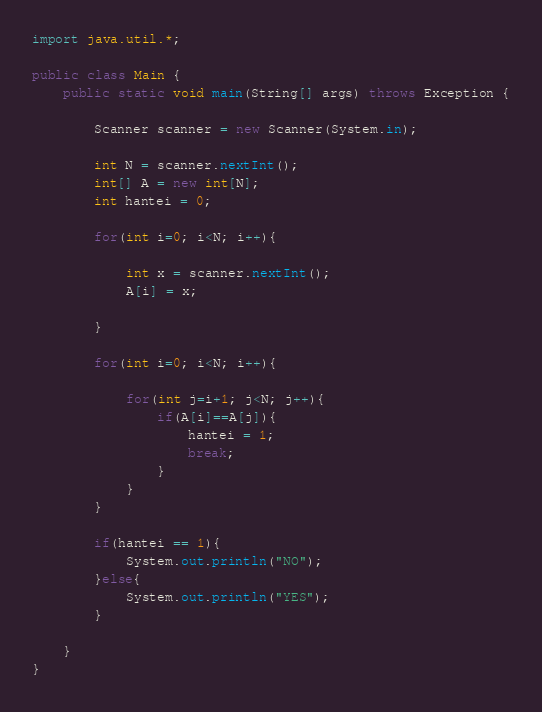<code> <loc_0><loc_0><loc_500><loc_500><_Java_>import java.util.*;

public class Main {
    public static void main(String[] args) throws Exception {
        
        Scanner scanner = new Scanner(System.in);
        
        int N = scanner.nextInt();
        int[] A = new int[N];
        int hantei = 0;
        
        for(int i=0; i<N; i++){
            
            int x = scanner.nextInt();
            A[i] = x;
            
        }
        
        for(int i=0; i<N; i++){
            
            for(int j=i+1; j<N; j++){
                if(A[i]==A[j]){
                    hantei = 1;
                    break;
                }
            }
        }
        
        if(hantei == 1){
            System.out.println("NO");
        }else{
            System.out.println("YES");
        }
        
    }
}</code> 